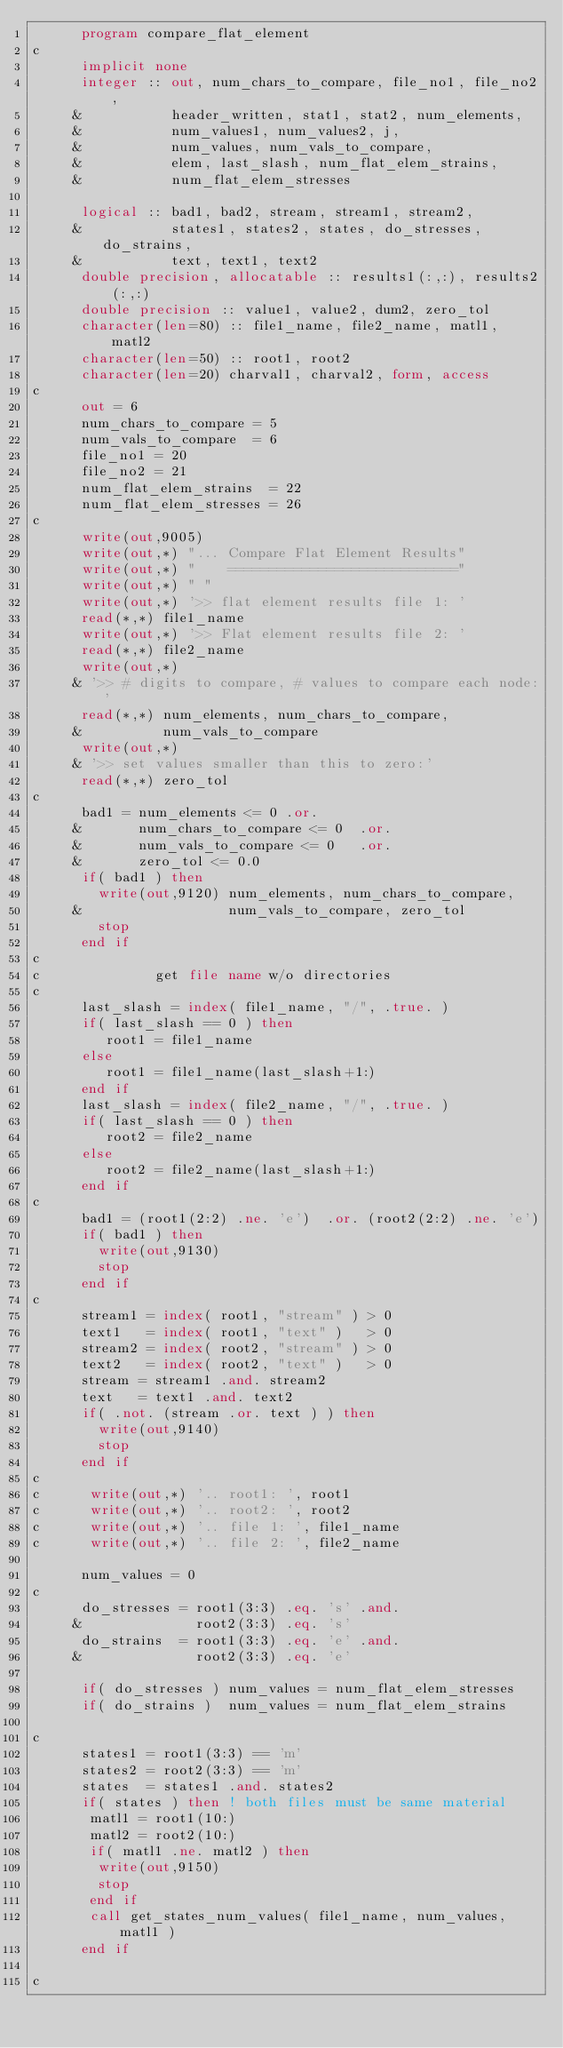Convert code to text. <code><loc_0><loc_0><loc_500><loc_500><_FORTRAN_>      program compare_flat_element 
c      
      implicit none
      integer :: out, num_chars_to_compare, file_no1, file_no2,
     &           header_written, stat1, stat2, num_elements,
     &           num_values1, num_values2, j,
     &           num_values, num_vals_to_compare,
     &           elem, last_slash, num_flat_elem_strains,
     &           num_flat_elem_stresses

      logical :: bad1, bad2, stream, stream1, stream2, 
     &           states1, states2, states, do_stresses, do_strains,
     &           text, text1, text2 
      double precision, allocatable :: results1(:,:), results2(:,:)
      double precision :: value1, value2, dum2, zero_tol
      character(len=80) :: file1_name, file2_name, matl1, matl2
      character(len=50) :: root1, root2
      character(len=20) charval1, charval2, form, access
c
      out = 6
      num_chars_to_compare = 5
      num_vals_to_compare  = 6
      file_no1 = 20
      file_no2 = 21
      num_flat_elem_strains  = 22
      num_flat_elem_stresses = 26
c      
      write(out,9005)
      write(out,*) "... Compare Flat Element Results"
      write(out,*) "    ============================"
      write(out,*) " "
      write(out,*) '>> flat element results file 1: '
      read(*,*) file1_name
      write(out,*) '>> Flat element results file 2: '
      read(*,*) file2_name 
      write(out,*) 
     & '>> # digits to compare, # values to compare each node:'
      read(*,*) num_elements, num_chars_to_compare,
     &          num_vals_to_compare
      write(out,*) 
     & '>> set values smaller than this to zero:'
      read(*,*) zero_tol
c
      bad1 = num_elements <= 0 .or.
     &       num_chars_to_compare <= 0  .or.
     &       num_vals_to_compare <= 0   .or.
     &       zero_tol <= 0.0  
      if( bad1 ) then
        write(out,9120) num_elements, num_chars_to_compare,
     &                  num_vals_to_compare, zero_tol
        stop
      end if  
c
c              get file name w/o directories
c
      last_slash = index( file1_name, "/", .true. )
      if( last_slash == 0 ) then
         root1 = file1_name
      else
         root1 = file1_name(last_slash+1:)
      end if
      last_slash = index( file2_name, "/", .true. )
      if( last_slash == 0 ) then
         root2 = file2_name
      else
         root2 = file2_name(last_slash+1:)
      end if
c
      bad1 = (root1(2:2) .ne. 'e')  .or. (root2(2:2) .ne. 'e')
      if( bad1 ) then
        write(out,9130)
        stop
      end if
c      
      stream1 = index( root1, "stream" ) > 0
      text1   = index( root1, "text" )   > 0
      stream2 = index( root2, "stream" ) > 0
      text2   = index( root2, "text" )   > 0
      stream = stream1 .and. stream2
      text   = text1 .and. text2
      if( .not. (stream .or. text ) ) then
        write(out,9140)
        stop
      end if
c
c      write(out,*) '.. root1: ', root1
c      write(out,*) '.. root2: ', root2
c      write(out,*) '.. file 1: ', file1_name
c      write(out,*) '.. file 2: ', file2_name

      num_values = 0
c      
      do_stresses = root1(3:3) .eq. 's' .and.
     &              root2(3:3) .eq. 's'
      do_strains  = root1(3:3) .eq. 'e' .and.
     &              root2(3:3) .eq. 'e'
       
      if( do_stresses ) num_values = num_flat_elem_stresses
      if( do_strains )  num_values = num_flat_elem_strains

c
      states1 = root1(3:3) == 'm'
      states2 = root2(3:3) == 'm'
      states  = states1 .and. states2
      if( states ) then ! both files must be same material
       matl1 = root1(10:)
       matl2 = root2(10:)
       if( matl1 .ne. matl2 ) then
        write(out,9150)
        stop
       end if
       call get_states_num_values( file1_name, num_values, matl1 )
      end if 

c    </code> 